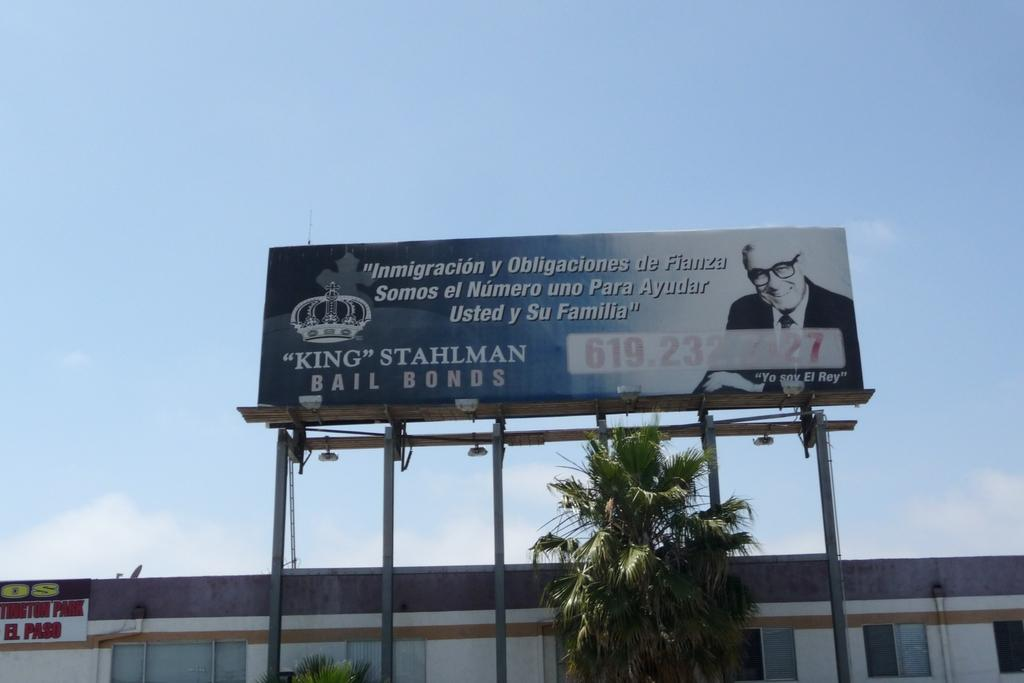<image>
Relay a brief, clear account of the picture shown. a bill board that has a bail bonds advertisement on it 